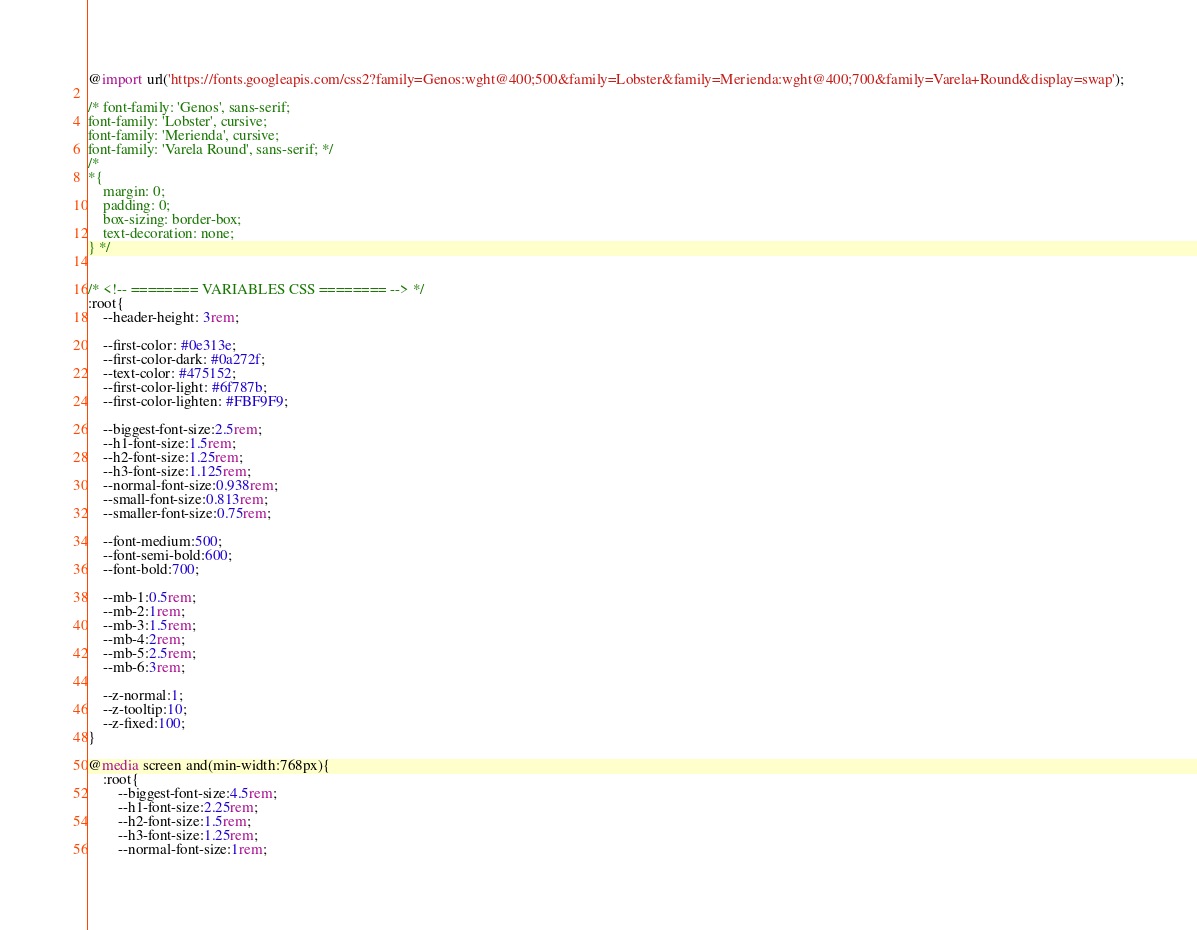<code> <loc_0><loc_0><loc_500><loc_500><_CSS_>@import url('https://fonts.googleapis.com/css2?family=Genos:wght@400;500&family=Lobster&family=Merienda:wght@400;700&family=Varela+Round&display=swap');

/* font-family: 'Genos', sans-serif;
font-family: 'Lobster', cursive;
font-family: 'Merienda', cursive;
font-family: 'Varela Round', sans-serif; */
/* 
*{
    margin: 0;
    padding: 0;
    box-sizing: border-box;
    text-decoration: none;
} */


/* <!-- ======== VARIABLES CSS ======== --> */
:root{
    --header-height: 3rem;

    --first-color: #0e313e;
    --first-color-dark: #0a272f;
    --text-color: #475152;
    --first-color-light: #6f787b;
    --first-color-lighten: #FBF9F9;

    --biggest-font-size:2.5rem;
    --h1-font-size:1.5rem;
    --h2-font-size:1.25rem;
    --h3-font-size:1.125rem;
    --normal-font-size:0.938rem;
    --small-font-size:0.813rem;
    --smaller-font-size:0.75rem;

    --font-medium:500;
    --font-semi-bold:600;
    --font-bold:700;

    --mb-1:0.5rem;
    --mb-2:1rem;
    --mb-3:1.5rem;
    --mb-4:2rem;
    --mb-5:2.5rem;
    --mb-6:3rem;

    --z-normal:1;
    --z-tooltip:10;
    --z-fixed:100;
}

@media screen and(min-width:768px){
    :root{
        --biggest-font-size:4.5rem;
        --h1-font-size:2.25rem;
        --h2-font-size:1.5rem;
        --h3-font-size:1.25rem;
        --normal-font-size:1rem;</code> 